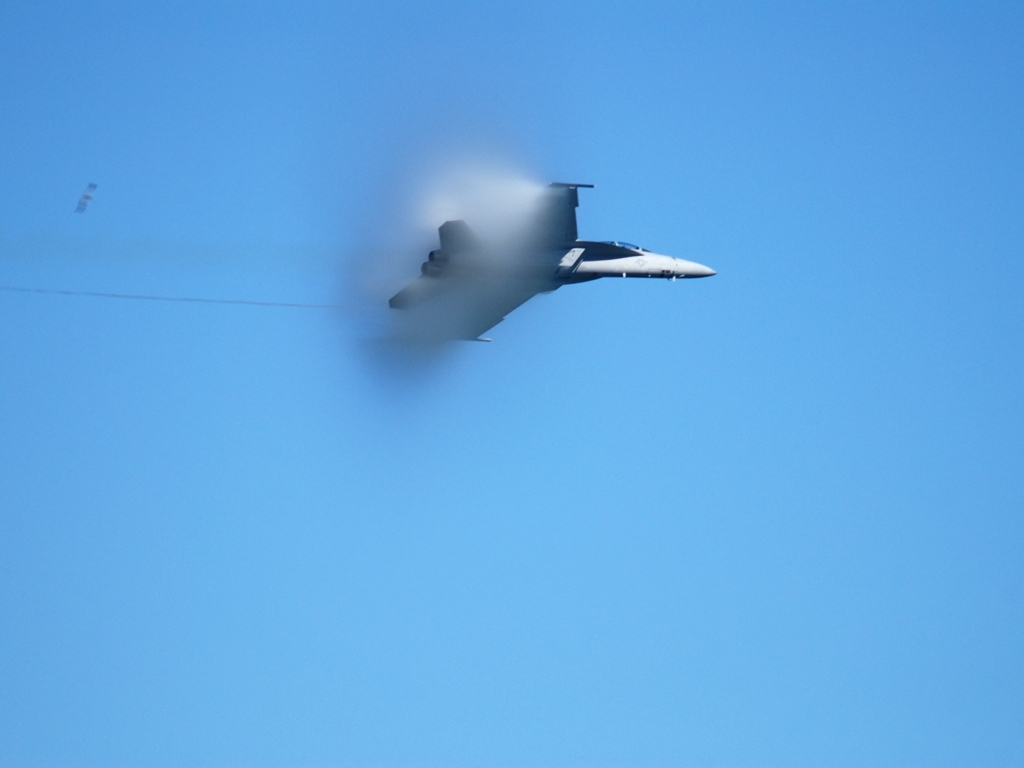What type of jet is shown in the image, based on its design? The exact model of the jet is not identifiable due to the image's limited details and the view angle. However, it exhibits features characteristic of modern military fighter jets, such as a sleek aerodynamic design, swept wings, and possibly twin engines, based on its silhouette. 